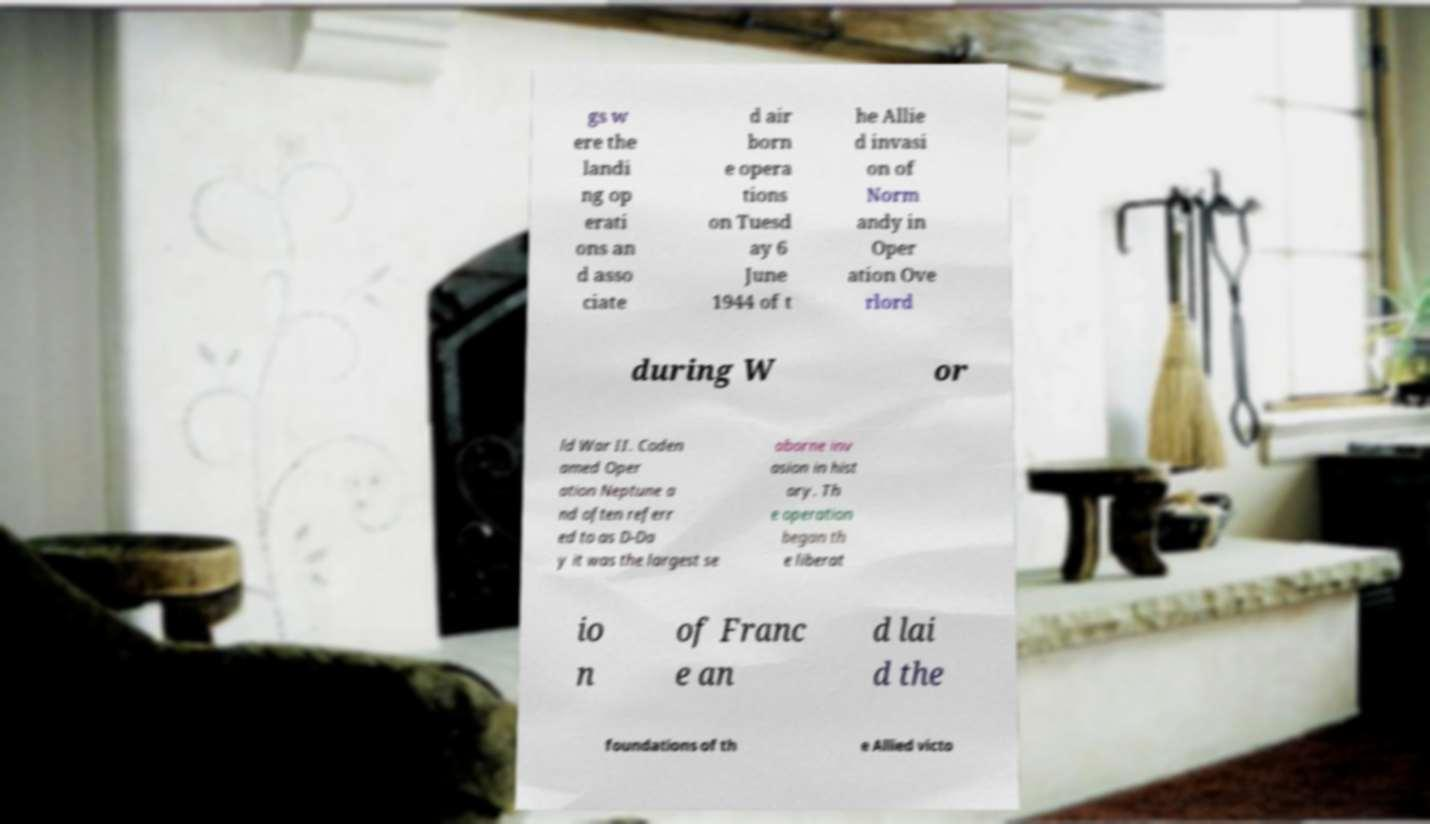I need the written content from this picture converted into text. Can you do that? gs w ere the landi ng op erati ons an d asso ciate d air born e opera tions on Tuesd ay 6 June 1944 of t he Allie d invasi on of Norm andy in Oper ation Ove rlord during W or ld War II. Coden amed Oper ation Neptune a nd often referr ed to as D-Da y it was the largest se aborne inv asion in hist ory. Th e operation began th e liberat io n of Franc e an d lai d the foundations of th e Allied victo 